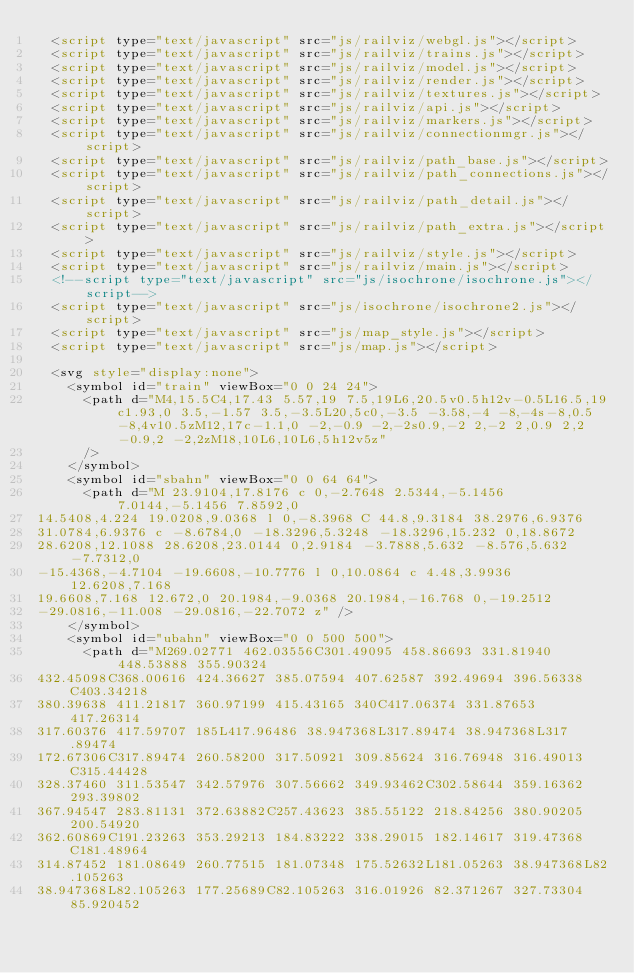Convert code to text. <code><loc_0><loc_0><loc_500><loc_500><_HTML_>  <script type="text/javascript" src="js/railviz/webgl.js"></script>
  <script type="text/javascript" src="js/railviz/trains.js"></script>
  <script type="text/javascript" src="js/railviz/model.js"></script>
  <script type="text/javascript" src="js/railviz/render.js"></script>
  <script type="text/javascript" src="js/railviz/textures.js"></script>
  <script type="text/javascript" src="js/railviz/api.js"></script>
  <script type="text/javascript" src="js/railviz/markers.js"></script>
  <script type="text/javascript" src="js/railviz/connectionmgr.js"></script>
  <script type="text/javascript" src="js/railviz/path_base.js"></script>
  <script type="text/javascript" src="js/railviz/path_connections.js"></script>
  <script type="text/javascript" src="js/railviz/path_detail.js"></script>
  <script type="text/javascript" src="js/railviz/path_extra.js"></script>
  <script type="text/javascript" src="js/railviz/style.js"></script>
  <script type="text/javascript" src="js/railviz/main.js"></script>
  <!--script type="text/javascript" src="js/isochrone/isochrone.js"></script-->
  <script type="text/javascript" src="js/isochrone/isochrone2.js"></script>
  <script type="text/javascript" src="js/map_style.js"></script>
  <script type="text/javascript" src="js/map.js"></script>

  <svg style="display:none">
    <symbol id="train" viewBox="0 0 24 24">
      <path d="M4,15.5C4,17.43 5.57,19 7.5,19L6,20.5v0.5h12v-0.5L16.5,19c1.93,0 3.5,-1.57 3.5,-3.5L20,5c0,-3.5 -3.58,-4 -8,-4s-8,0.5 -8,4v10.5zM12,17c-1.1,0 -2,-0.9 -2,-2s0.9,-2 2,-2 2,0.9 2,2 -0.9,2 -2,2zM18,10L6,10L6,5h12v5z"
      />
    </symbol>
    <symbol id="sbahn" viewBox="0 0 64 64">
      <path d="M 23.9104,17.8176 c 0,-2.7648 2.5344,-5.1456 7.0144,-5.1456 7.8592,0
14.5408,4.224 19.0208,9.0368 l 0,-8.3968 C 44.8,9.3184 38.2976,6.9376
31.0784,6.9376 c -8.6784,0 -18.3296,5.3248 -18.3296,15.232 0,18.8672
28.6208,12.1088 28.6208,23.0144 0,2.9184 -3.7888,5.632 -8.576,5.632 -7.7312,0
-15.4368,-4.7104 -19.6608,-10.7776 l 0,10.0864 c 4.48,3.9936 12.6208,7.168
19.6608,7.168 12.672,0 20.1984,-9.0368 20.1984,-16.768 0,-19.2512
-29.0816,-11.008 -29.0816,-22.7072 z" />
    </symbol>
    <symbol id="ubahn" viewBox="0 0 500 500">
      <path d="M269.02771 462.03556C301.49095 458.86693 331.81940 448.53888 355.90324
432.45098C368.00616 424.36627 385.07594 407.62587 392.49694 396.56338C403.34218
380.39638 411.21817 360.97199 415.43165 340C417.06374 331.87653 417.26314
317.60376 417.59707 185L417.96486 38.947368L317.89474 38.947368L317.89474
172.67306C317.89474 260.58200 317.50921 309.85624 316.76948 316.49013C315.44428
328.37460 311.53547 342.57976 307.56662 349.93462C302.58644 359.16362 293.39802
367.94547 283.81131 372.63882C257.43623 385.55122 218.84256 380.90205 200.54920
362.60869C191.23263 353.29213 184.83222 338.29015 182.14617 319.47368C181.48964
314.87452 181.08649 260.77515 181.07348 175.52632L181.05263 38.947368L82.105263
38.947368L82.105263 177.25689C82.105263 316.01926 82.371267 327.73304 85.920452</code> 